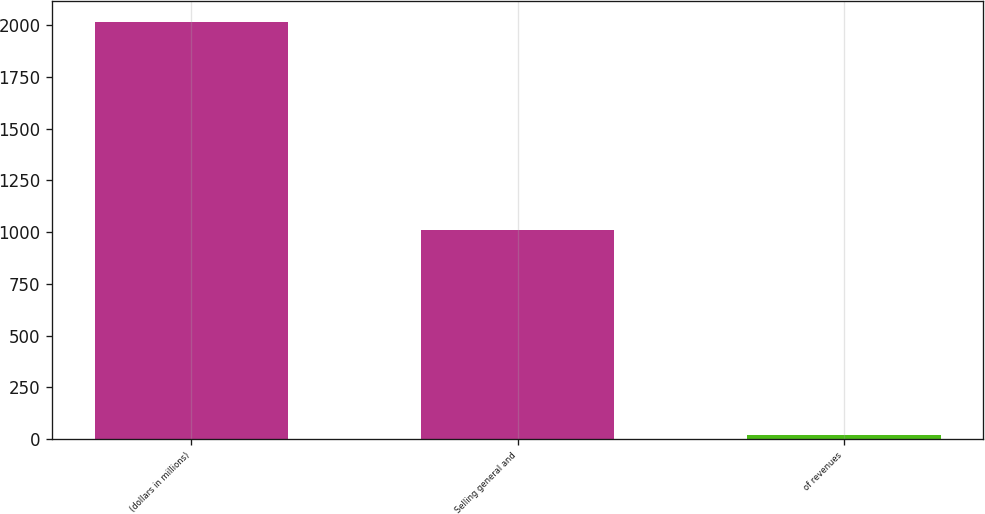<chart> <loc_0><loc_0><loc_500><loc_500><bar_chart><fcel>(dollars in millions)<fcel>Selling general and<fcel>of revenues<nl><fcel>2016<fcel>1011<fcel>18.8<nl></chart> 